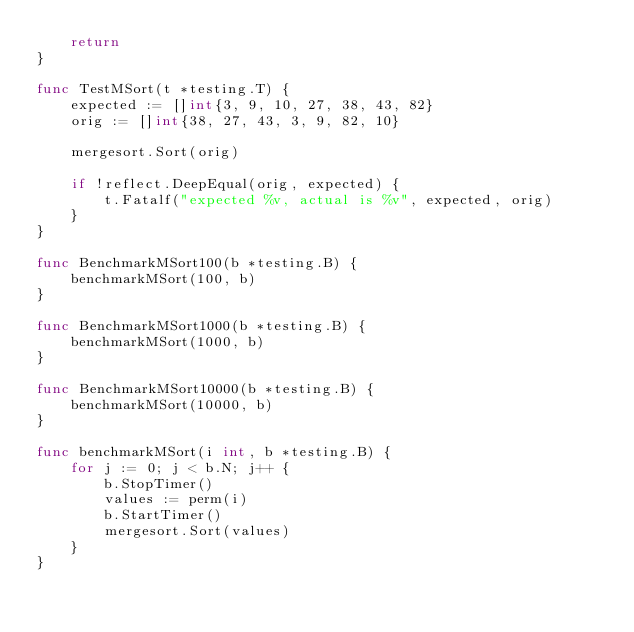Convert code to text. <code><loc_0><loc_0><loc_500><loc_500><_Go_>    return
}

func TestMSort(t *testing.T) {
    expected := []int{3, 9, 10, 27, 38, 43, 82}
    orig := []int{38, 27, 43, 3, 9, 82, 10}

    mergesort.Sort(orig)

    if !reflect.DeepEqual(orig, expected) {
        t.Fatalf("expected %v, actual is %v", expected, orig)
    }
}

func BenchmarkMSort100(b *testing.B) {
    benchmarkMSort(100, b)
}

func BenchmarkMSort1000(b *testing.B) {
    benchmarkMSort(1000, b)
}

func BenchmarkMSort10000(b *testing.B) {
    benchmarkMSort(10000, b)
}

func benchmarkMSort(i int, b *testing.B) {
    for j := 0; j < b.N; j++ {
        b.StopTimer()
        values := perm(i)
        b.StartTimer()
        mergesort.Sort(values)
    }
}
</code> 